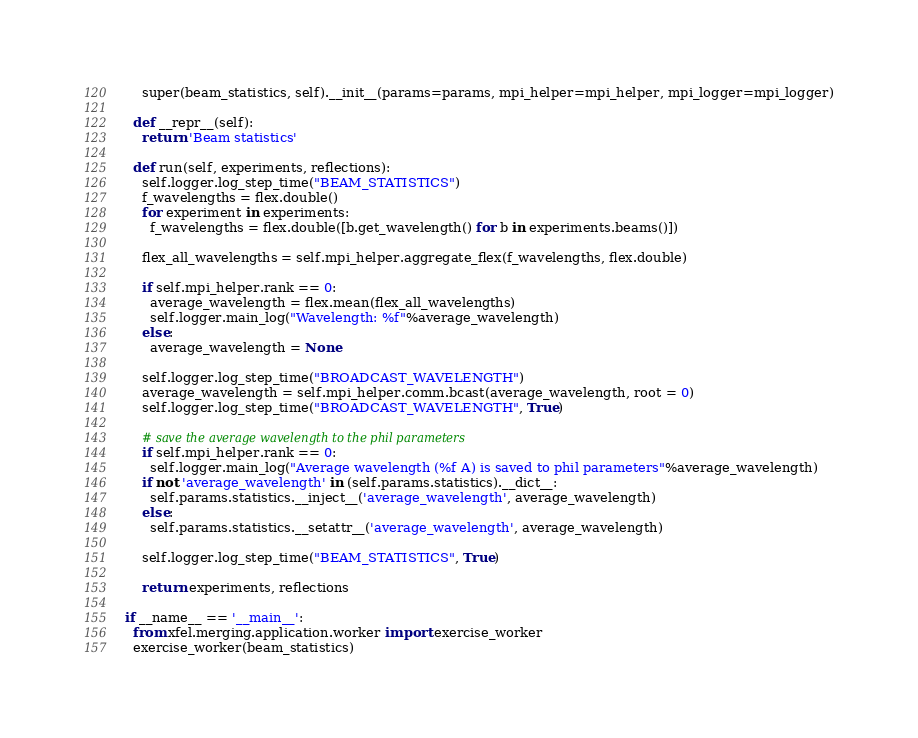<code> <loc_0><loc_0><loc_500><loc_500><_Python_>    super(beam_statistics, self).__init__(params=params, mpi_helper=mpi_helper, mpi_logger=mpi_logger)

  def __repr__(self):
    return 'Beam statistics'

  def run(self, experiments, reflections):
    self.logger.log_step_time("BEAM_STATISTICS")
    f_wavelengths = flex.double()
    for experiment in experiments:
      f_wavelengths = flex.double([b.get_wavelength() for b in experiments.beams()])

    flex_all_wavelengths = self.mpi_helper.aggregate_flex(f_wavelengths, flex.double)

    if self.mpi_helper.rank == 0:
      average_wavelength = flex.mean(flex_all_wavelengths)
      self.logger.main_log("Wavelength: %f"%average_wavelength)
    else:
      average_wavelength = None

    self.logger.log_step_time("BROADCAST_WAVELENGTH")
    average_wavelength = self.mpi_helper.comm.bcast(average_wavelength, root = 0)
    self.logger.log_step_time("BROADCAST_WAVELENGTH", True)

    # save the average wavelength to the phil parameters
    if self.mpi_helper.rank == 0:
      self.logger.main_log("Average wavelength (%f A) is saved to phil parameters"%average_wavelength)
    if not 'average_wavelength' in (self.params.statistics).__dict__:
      self.params.statistics.__inject__('average_wavelength', average_wavelength)
    else:
      self.params.statistics.__setattr__('average_wavelength', average_wavelength)

    self.logger.log_step_time("BEAM_STATISTICS", True)

    return experiments, reflections

if __name__ == '__main__':
  from xfel.merging.application.worker import exercise_worker
  exercise_worker(beam_statistics)
</code> 